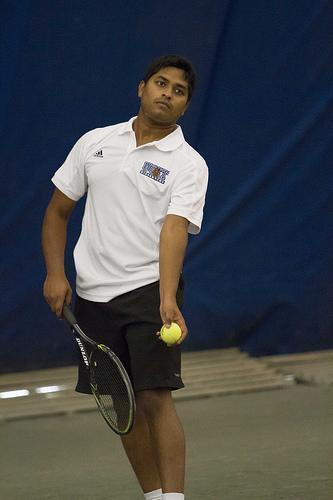How many men are there?
Give a very brief answer. 1. 